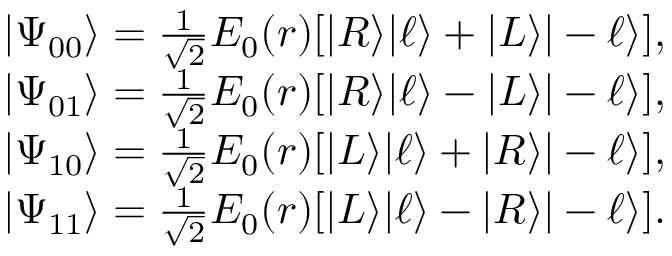Convert formula to latex. <formula><loc_0><loc_0><loc_500><loc_500>\begin{array} { r } { | \Psi _ { 0 0 } \rangle = \frac { 1 } { \sqrt { 2 } } E _ { 0 } ( r ) [ | R \rangle | \ell \rangle + | L \rangle | - \ell \rangle ] , } \\ { | \Psi _ { 0 1 } \rangle = \frac { 1 } { \sqrt { 2 } } E _ { 0 } ( r ) [ | R \rangle | \ell \rangle - | L \rangle | - \ell \rangle ] , } \\ { | \Psi _ { 1 0 } \rangle = \frac { 1 } { \sqrt { 2 } } E _ { 0 } ( r ) [ | L \rangle | \ell \rangle + | R \rangle | - \ell \rangle ] , } \\ { | \Psi _ { 1 1 } \rangle = \frac { 1 } { \sqrt { 2 } } E _ { 0 } ( r ) [ | L \rangle | \ell \rangle - | R \rangle | - \ell \rangle ] . } \end{array}</formula> 